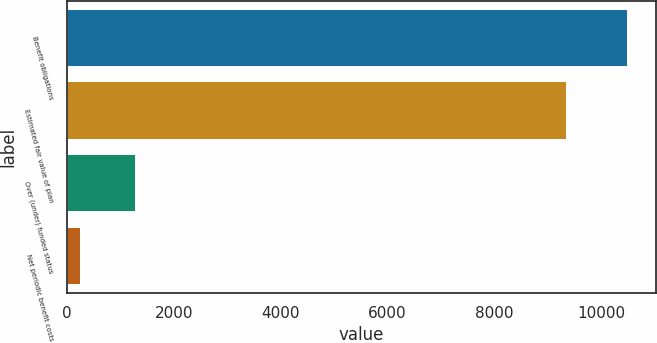<chart> <loc_0><loc_0><loc_500><loc_500><bar_chart><fcel>Benefit obligations<fcel>Estimated fair value of plan<fcel>Over (under) funded status<fcel>Net periodic benefit costs<nl><fcel>10500<fcel>9371<fcel>1290.3<fcel>267<nl></chart> 